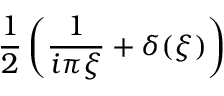<formula> <loc_0><loc_0><loc_500><loc_500>{ \frac { 1 } { 2 } } \left ( { \frac { 1 } { i \pi \xi } } + \delta ( \xi ) \right )</formula> 